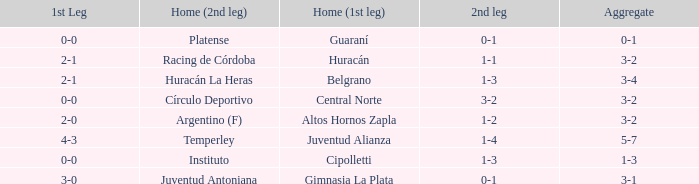Which team played the 2nd leg at home with a tie of 1-1 and scored 3-2 in aggregate? Racing de Córdoba. 